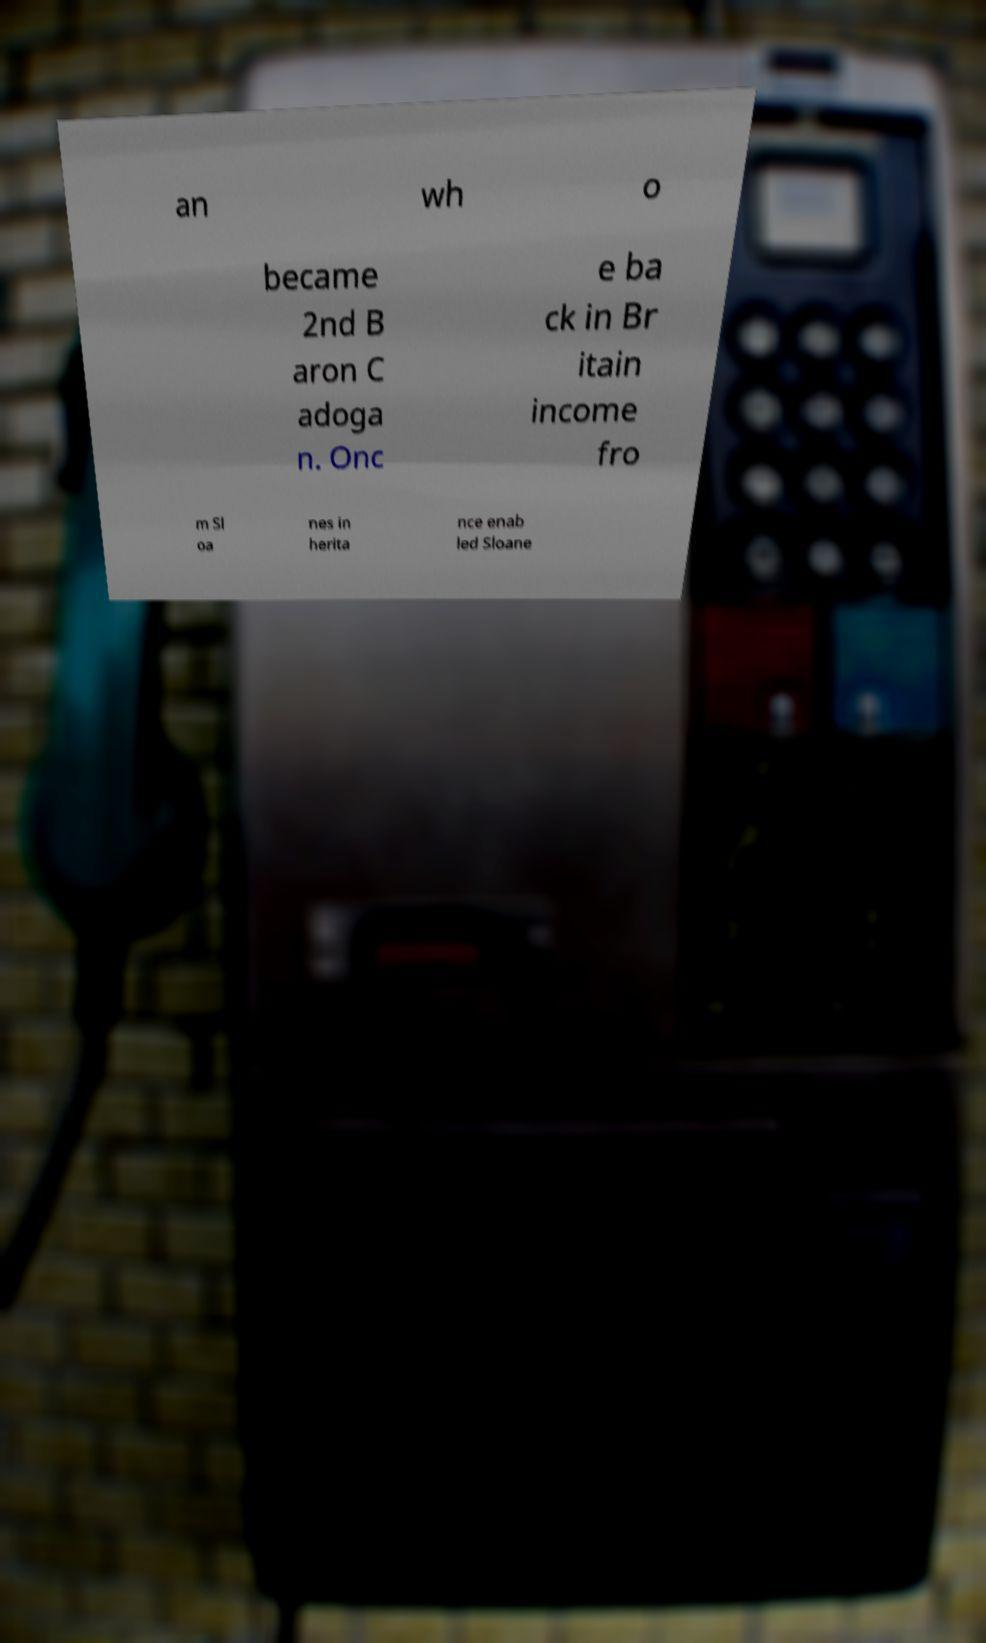Can you accurately transcribe the text from the provided image for me? an wh o became 2nd B aron C adoga n. Onc e ba ck in Br itain income fro m Sl oa nes in herita nce enab led Sloane 